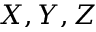<formula> <loc_0><loc_0><loc_500><loc_500>X , Y , Z</formula> 